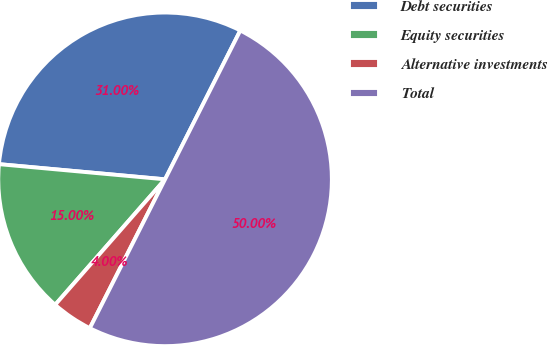Convert chart. <chart><loc_0><loc_0><loc_500><loc_500><pie_chart><fcel>Debt securities<fcel>Equity securities<fcel>Alternative investments<fcel>Total<nl><fcel>31.0%<fcel>15.0%<fcel>4.0%<fcel>50.0%<nl></chart> 